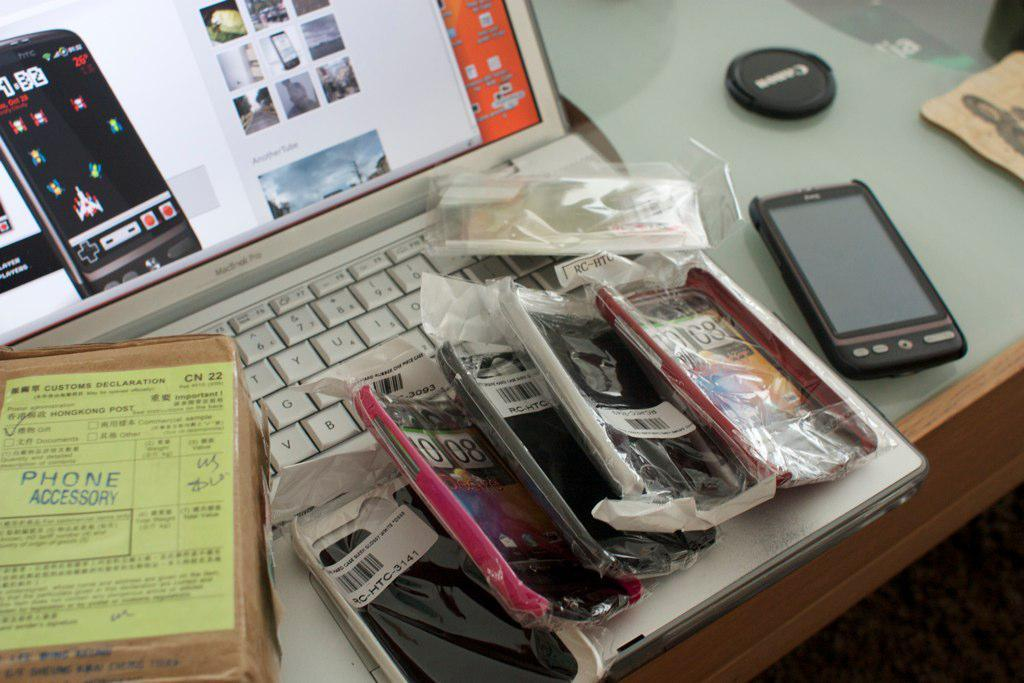What piece of furniture is present in the image? There is a table in the image. What electronic device is placed on the table? There is a laptop on the table. What additional items can be seen on the table? There are mobile phone covers on the table. Where is the ornament hanging in the image? There is no ornament present in the image. Can you see a swing in the image? There is no swing present in the image. 